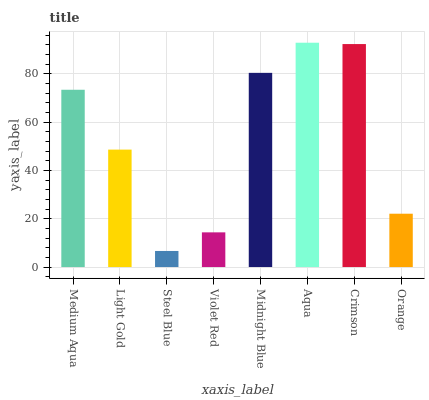Is Steel Blue the minimum?
Answer yes or no. Yes. Is Aqua the maximum?
Answer yes or no. Yes. Is Light Gold the minimum?
Answer yes or no. No. Is Light Gold the maximum?
Answer yes or no. No. Is Medium Aqua greater than Light Gold?
Answer yes or no. Yes. Is Light Gold less than Medium Aqua?
Answer yes or no. Yes. Is Light Gold greater than Medium Aqua?
Answer yes or no. No. Is Medium Aqua less than Light Gold?
Answer yes or no. No. Is Medium Aqua the high median?
Answer yes or no. Yes. Is Light Gold the low median?
Answer yes or no. Yes. Is Light Gold the high median?
Answer yes or no. No. Is Orange the low median?
Answer yes or no. No. 